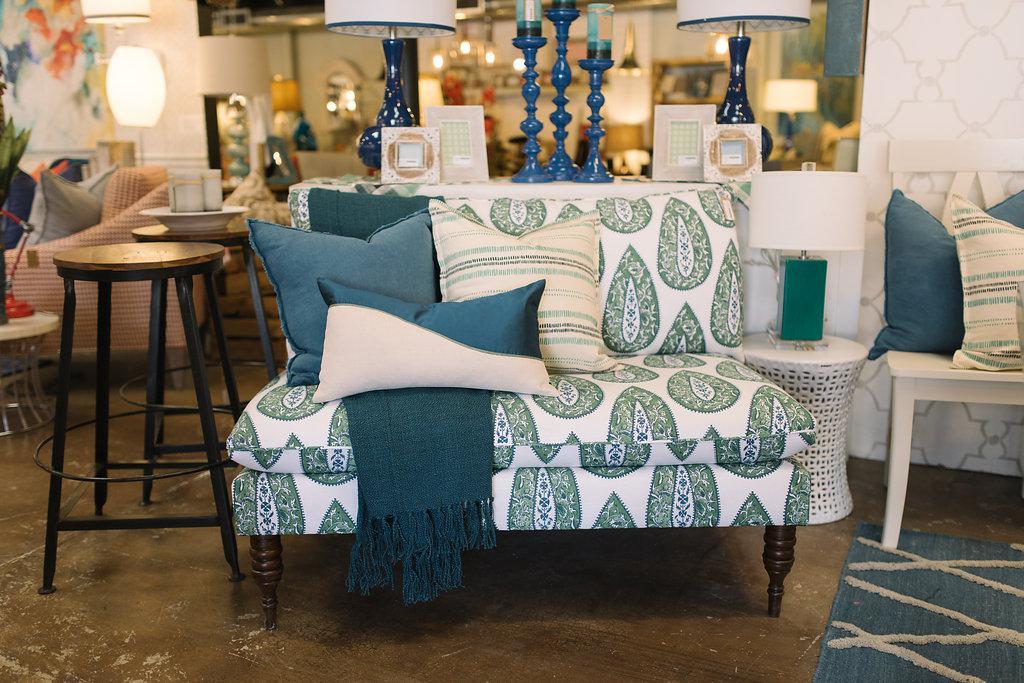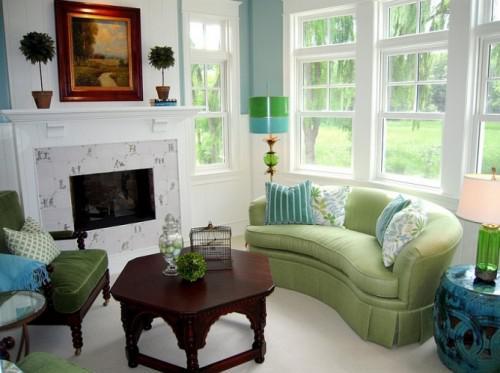The first image is the image on the left, the second image is the image on the right. Given the left and right images, does the statement "Both images show a vase of flowers sitting on top of a coffee table." hold true? Answer yes or no. No. The first image is the image on the left, the second image is the image on the right. For the images displayed, is the sentence "The combined images include a solid green sofa, green cylindrical shape, green plant, and green printed pillows." factually correct? Answer yes or no. Yes. 